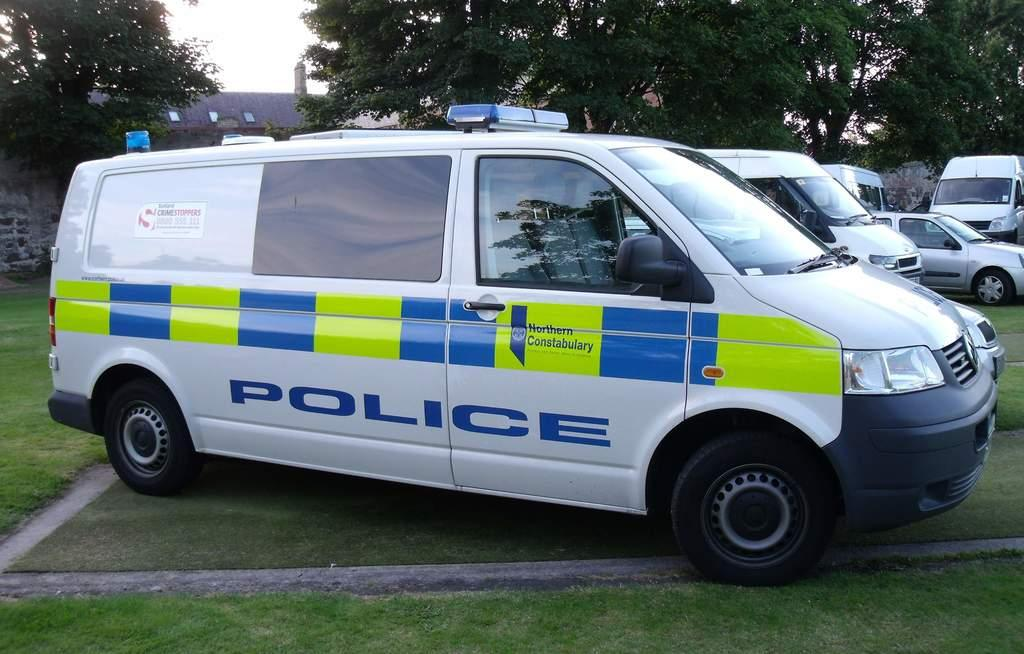<image>
Relay a brief, clear account of the picture shown. white police van parked on a patch of grass 